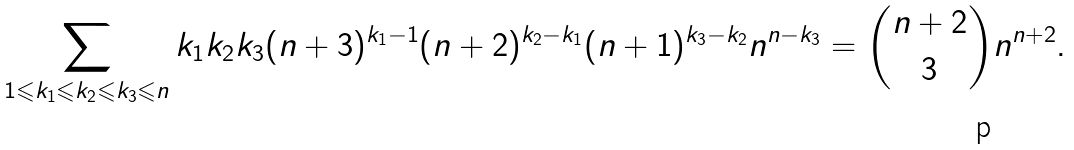Convert formula to latex. <formula><loc_0><loc_0><loc_500><loc_500>\sum _ { 1 \leqslant k _ { 1 } \leqslant k _ { 2 } \leqslant k _ { 3 } \leqslant n } k _ { 1 } k _ { 2 } k _ { 3 } ( n + 3 ) ^ { k _ { 1 } - 1 } ( n + 2 ) ^ { k _ { 2 } - k _ { 1 } } ( n + 1 ) ^ { k _ { 3 } - k _ { 2 } } n ^ { n - k _ { 3 } } = { n + 2 \choose 3 } n ^ { n + 2 } .</formula> 